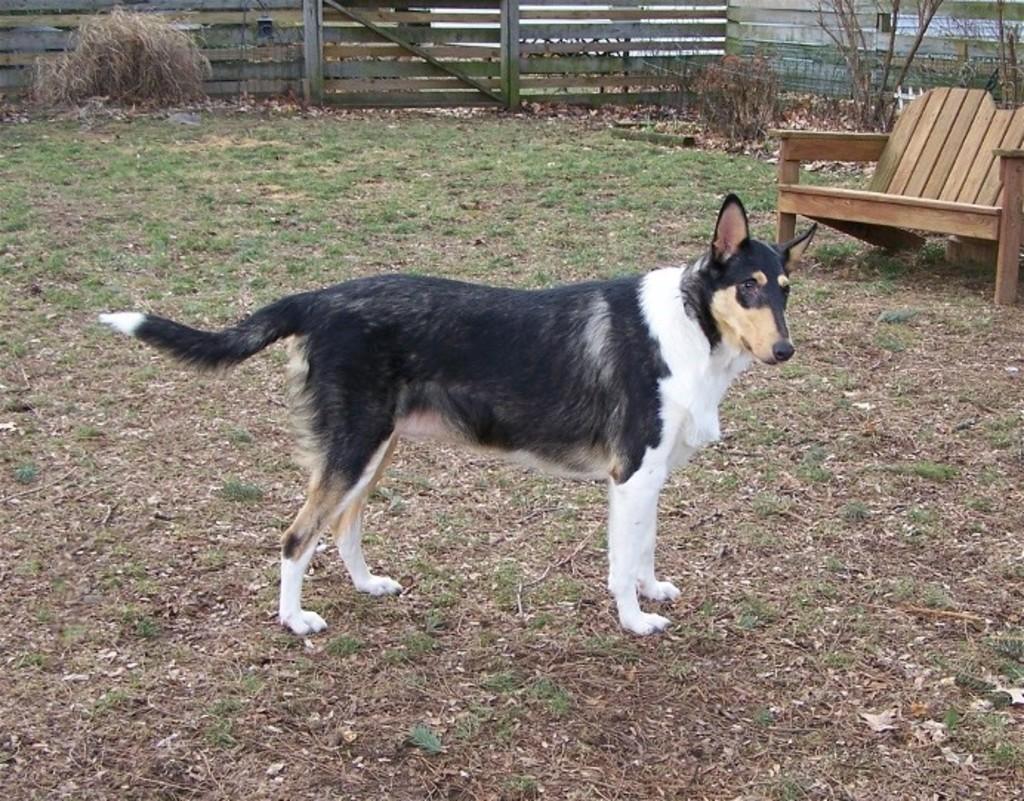Can you describe this image briefly? In the image we can see dog is standing on the ground and beside the dog there is a bench and at the back there is a fencing. 